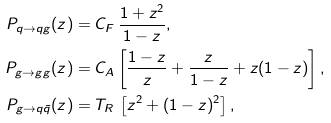<formula> <loc_0><loc_0><loc_500><loc_500>P _ { q \to q g } ( z ) & = C _ { F } \, \frac { 1 + z ^ { 2 } } { 1 - z } , \\ P _ { g \to g g } ( z ) & = C _ { A } \left [ \frac { 1 - z } { z } + \frac { z } { 1 - z } + z ( 1 - z ) \right ] , \\ P _ { g \to q \bar { q } } ( z ) & = T _ { R } \, \left [ z ^ { 2 } + ( 1 - z ) ^ { 2 } \right ] ,</formula> 